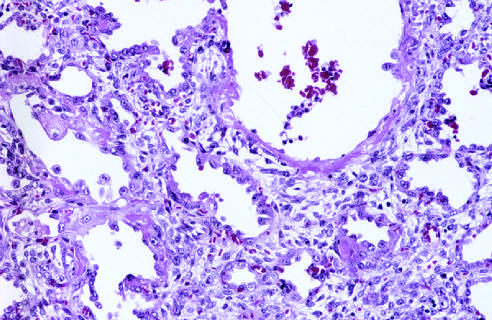s the right ventricle marked by resorption of hyaline membranes and thickening of alveolar septa by inflammatory cells, fibroblasts, and collagen?
Answer the question using a single word or phrase. No 